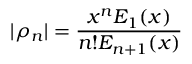Convert formula to latex. <formula><loc_0><loc_0><loc_500><loc_500>| \rho _ { n } | = \frac { x ^ { n } E _ { 1 } ( x ) } { n ! E _ { n + 1 } ( x ) }</formula> 